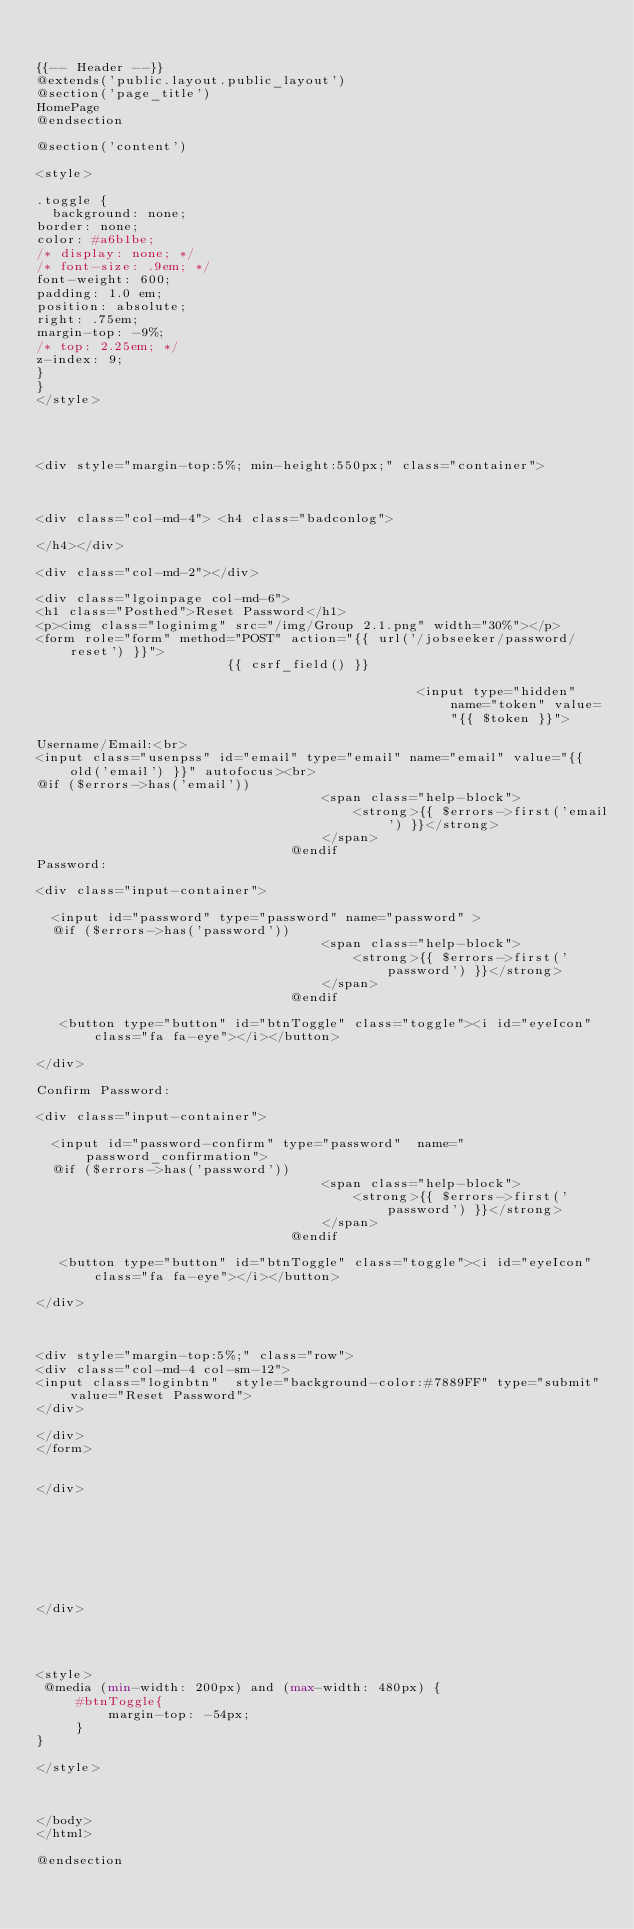<code> <loc_0><loc_0><loc_500><loc_500><_PHP_>

{{-- Header --}}
@extends('public.layout.public_layout')
@section('page_title')
HomePage
@endsection

@section('content')
 
<style>

.toggle {
  background: none;
border: none;
color: #a6b1be;
/* display: none; */
/* font-size: .9em; */
font-weight: 600;
padding: 1.0 em;
position: absolute;
right: .75em;
margin-top: -9%;
/* top: 2.25em; */
z-index: 9;
}
}
</style>




<div style="margin-top:5%; min-height:550px;" class="container"> 



<div class="col-md-4"> <h4 class="badconlog"> 

</h4></div> 	

<div class="col-md-2"></div>

<div class="lgoinpage col-md-6">
<h1 class="Posthed">Reset Password</h1>
<p><img class="loginimg" src="/img/Group 2.1.png" width="30%"></p>
<form role="form" method="POST" action="{{ url('/jobseeker/password/reset') }}">
                        {{ csrf_field() }}

                                                <input type="hidden" name="token" value="{{ $token }}">

Username/Email:<br>
<input class="usenpss" id="email" type="email" name="email" value="{{ old('email') }}" autofocus><br>
@if ($errors->has('email'))
                                    <span class="help-block">
                                        <strong>{{ $errors->first('email') }}</strong>
                                    </span>
                                @endif
Password:

<div class="input-container">

  <input id="password" type="password" name="password" >
  @if ($errors->has('password'))
                                    <span class="help-block">
                                        <strong>{{ $errors->first('password') }}</strong>
                                    </span>
                                @endif
                           
   <button type="button" id="btnToggle" class="toggle"><i id="eyeIcon" class="fa fa-eye"></i></button>
      
</div>

Confirm Password:

<div class="input-container">

  <input id="password-confirm" type="password"  name="password_confirmation">
  @if ($errors->has('password'))
                                    <span class="help-block">
                                        <strong>{{ $errors->first('password') }}</strong>
                                    </span>
                                @endif
                           
   <button type="button" id="btnToggle" class="toggle"><i id="eyeIcon" class="fa fa-eye"></i></button>
      
</div>


                       
<div style="margin-top:5%;" class="row">
<div class="col-md-4 col-sm-12">
<input class="loginbtn"  style="background-color:#7889FF" type="submit" value="Reset Password">
</div>

</div>
</form>


</div> 








</div>




<style>
 @media (min-width: 200px) and (max-width: 480px) {
     #btnToggle{
         margin-top: -54px;
     }
} 

</style>



</body>
</html>

@endsection

</code> 